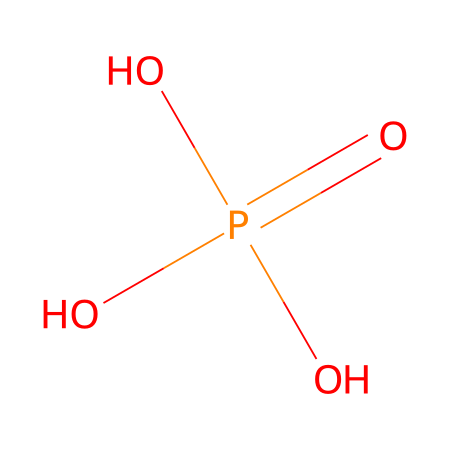What is the molecular formula of the compound shown? The chemical structure can be analyzed systematically. The notation OP(=O)(O)O indicates there is one phosphorus (P) atom, four oxygen (O) atoms, so the molecular formula is composed of those elements, which is P4O4, but upon adjusting the counts properly, leads us to the recognizable formula of H3PO4 (Phosphoric acid).
Answer: H3PO4 How many oxygen atoms are present in this structure? By examining the SMILES representation, we can see the "O" characters listed. According to the molecular notation, there are four oxygen atoms signified by four "O" including those involved in bonding with phosphorus as well as the hydroxyl groups.
Answer: Four What type of bond is primarily present between phosphorus and oxygen in this compound? The chemical structure shows that phosphorus is bonded to multiple oxygen atoms through covalent bonds. The nature of these attachments indicates strong covalent bonding due to sharing electrons between the phosphorus atom and each oxygen atom, differing from ionic bonds.
Answer: Covalent What is the charge of this phosphate ion? In molecular terms, phosphate is understood to carry a negative charge. Given this structure includes three -OH (hydroxyl) groups, it contributes more electrons which further indicates a -3 charge overall.
Answer: Negative three Is this compound hydrophilic? The structure contains hydroxyl (-OH) groups which indicates that this compound is water-soluble when dissolved, hence making it hydrophilic (attracts water). The polar nature of these functional groups leads to affinity with water molecules.
Answer: Yes What kind of fertilizer typically includes this compound? Phosphate fertilizers are commonly associated with enhancing plant growth, and the chemical structure presented corresponds to phosphoric acid, which is a key nutrient source in fertilizers used in agriculture.
Answer: Phosphate 